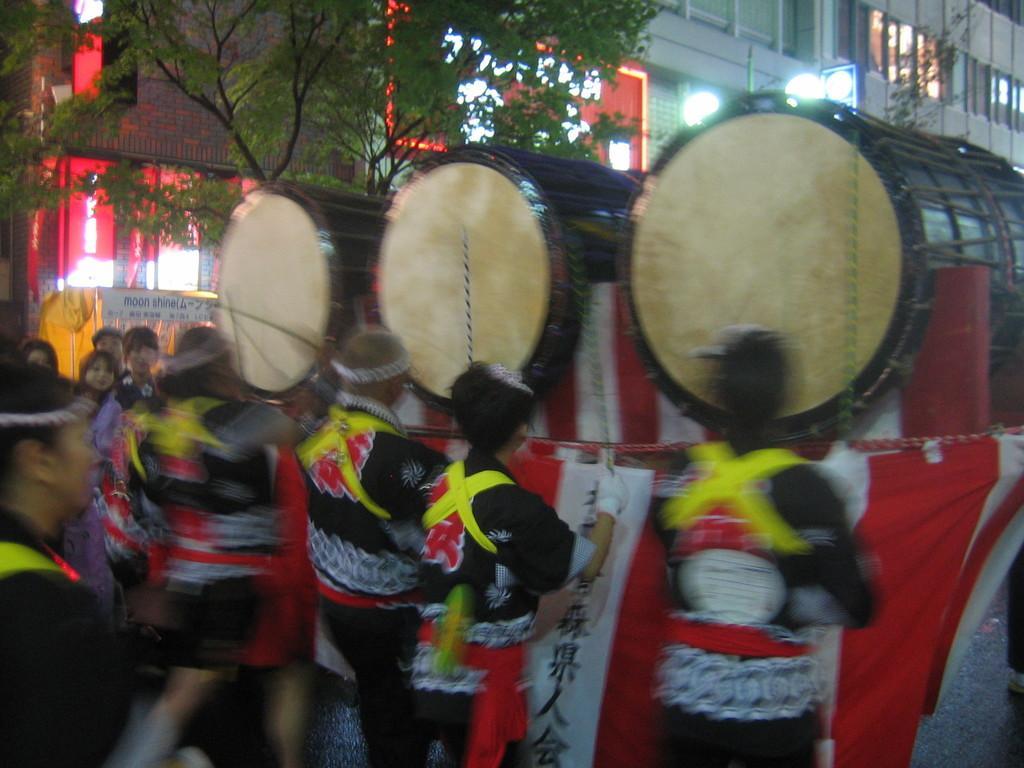In one or two sentences, can you explain what this image depicts? This is a picture taken in the outdoors. There are group of people playing the music instrument. Background of this people is a tree and building. 